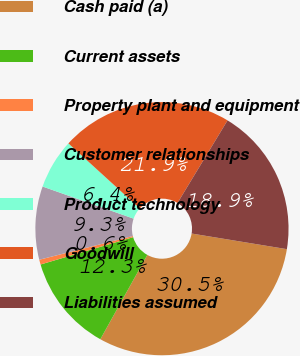Convert chart. <chart><loc_0><loc_0><loc_500><loc_500><pie_chart><fcel>Cash paid (a)<fcel>Current assets<fcel>Property plant and equipment<fcel>Customer relationships<fcel>Product technology<fcel>Goodwill<fcel>Liabilities assumed<nl><fcel>30.51%<fcel>12.34%<fcel>0.62%<fcel>9.35%<fcel>6.36%<fcel>21.91%<fcel>18.92%<nl></chart> 